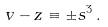<formula> <loc_0><loc_0><loc_500><loc_500>v - z \equiv \pm s ^ { 3 } \, .</formula> 